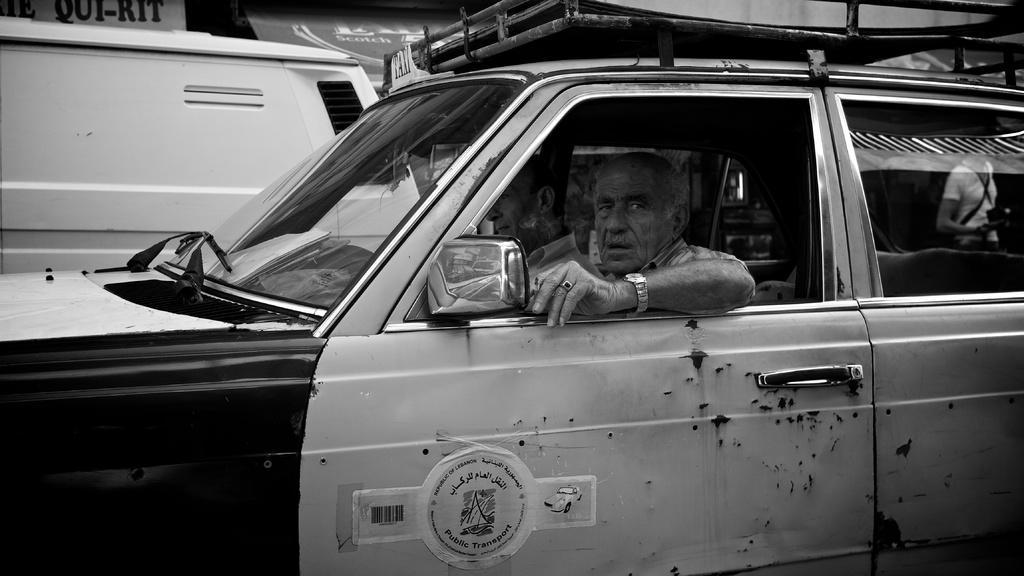In one or two sentences, can you explain what this image depicts? This is completely a black and white picture. Here we can see two men sitting inside a car. Here on a car glass we can see the reflection of other person. This is a board at the top of the picture. 